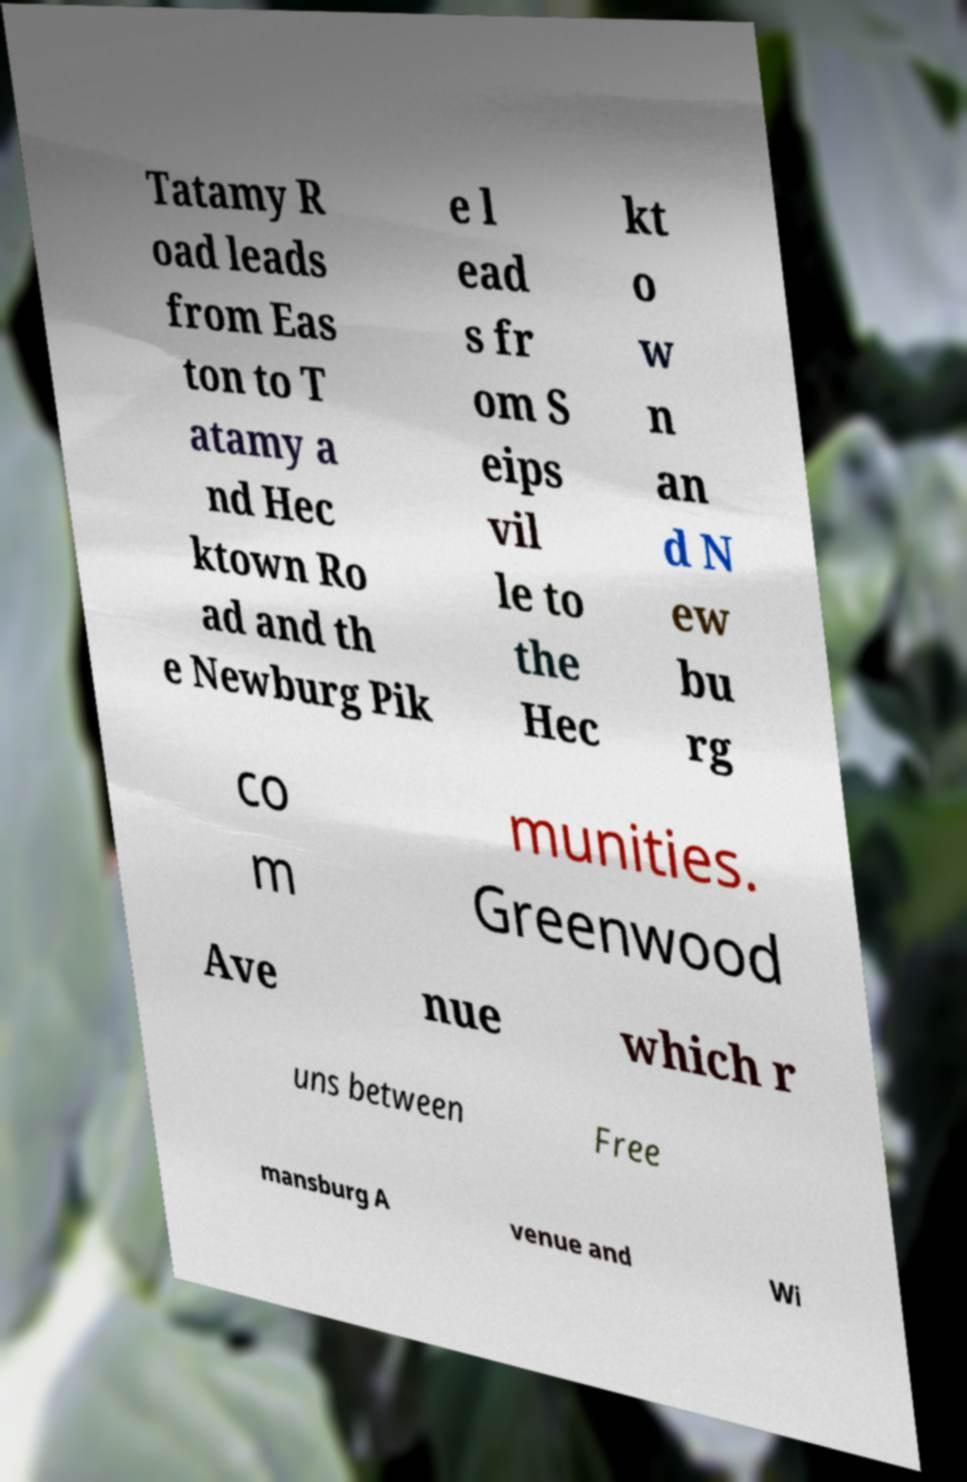Can you accurately transcribe the text from the provided image for me? Tatamy R oad leads from Eas ton to T atamy a nd Hec ktown Ro ad and th e Newburg Pik e l ead s fr om S eips vil le to the Hec kt o w n an d N ew bu rg co m munities. Greenwood Ave nue which r uns between Free mansburg A venue and Wi 